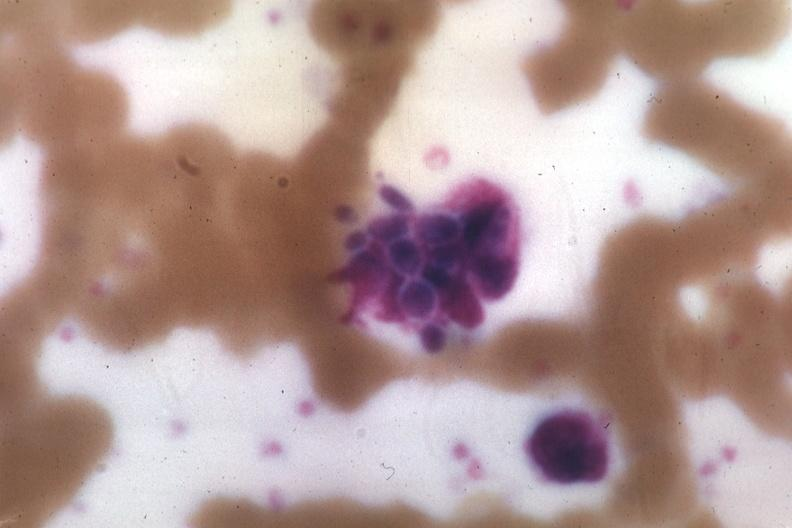s blood present?
Answer the question using a single word or phrase. Yes 